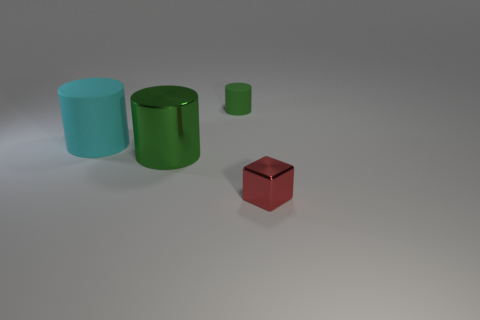Subtract all green balls. How many green cylinders are left? 2 Add 2 green cylinders. How many objects exist? 6 Subtract all cylinders. How many objects are left? 1 Add 3 rubber cylinders. How many rubber cylinders are left? 5 Add 3 large green cylinders. How many large green cylinders exist? 4 Subtract 0 yellow cubes. How many objects are left? 4 Subtract all big green metallic objects. Subtract all large yellow objects. How many objects are left? 3 